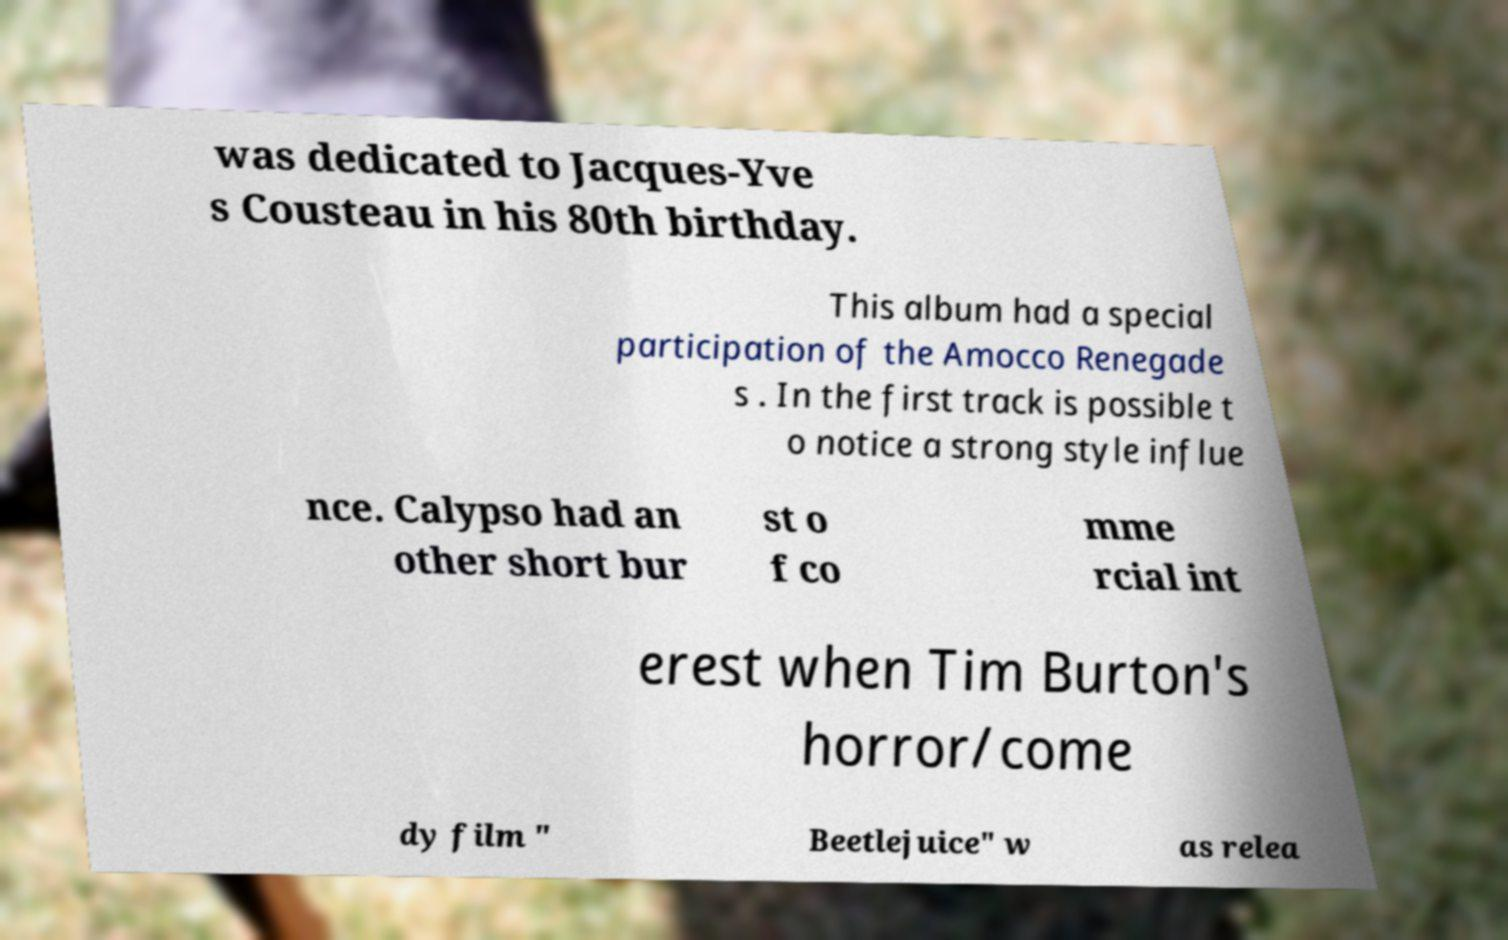What messages or text are displayed in this image? I need them in a readable, typed format. was dedicated to Jacques-Yve s Cousteau in his 80th birthday. This album had a special participation of the Amocco Renegade s . In the first track is possible t o notice a strong style influe nce. Calypso had an other short bur st o f co mme rcial int erest when Tim Burton's horror/come dy film " Beetlejuice" w as relea 